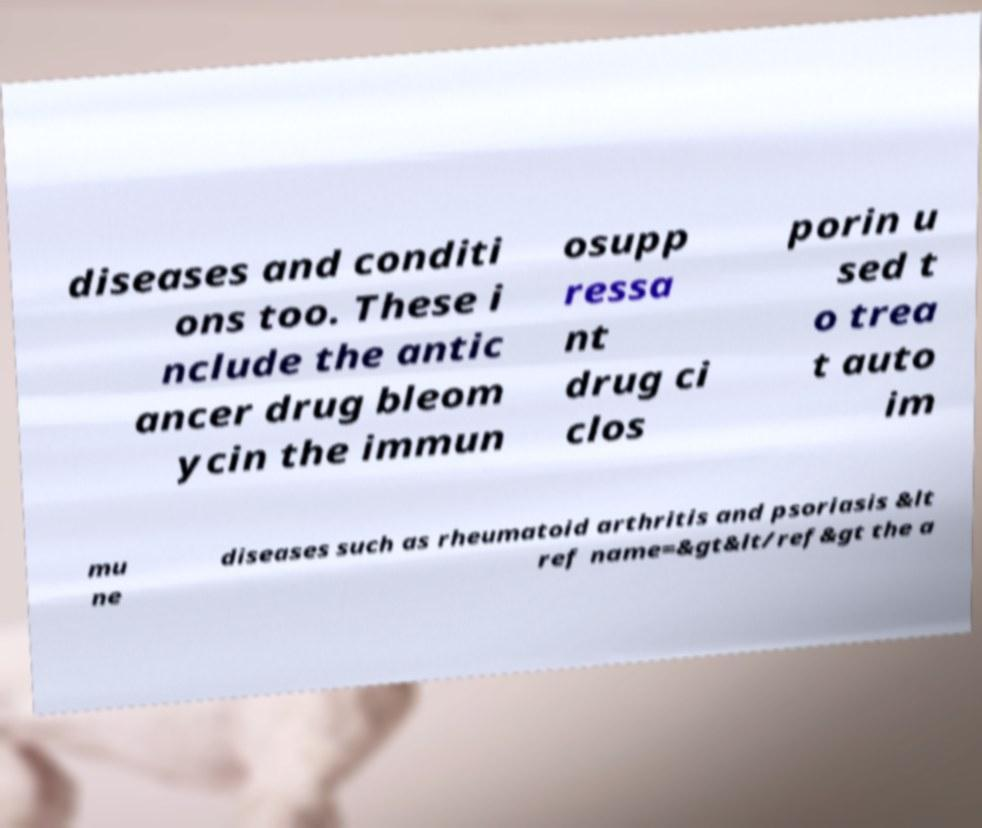What messages or text are displayed in this image? I need them in a readable, typed format. diseases and conditi ons too. These i nclude the antic ancer drug bleom ycin the immun osupp ressa nt drug ci clos porin u sed t o trea t auto im mu ne diseases such as rheumatoid arthritis and psoriasis &lt ref name=&gt&lt/ref&gt the a 